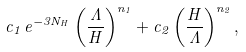<formula> <loc_0><loc_0><loc_500><loc_500>c _ { 1 } \, e ^ { - 3 N _ { H } } \left ( \frac { \Lambda } { H } \right ) ^ { n _ { 1 } } + c _ { 2 } \left ( \frac { H } { \Lambda } \right ) ^ { n _ { 2 } } ,</formula> 